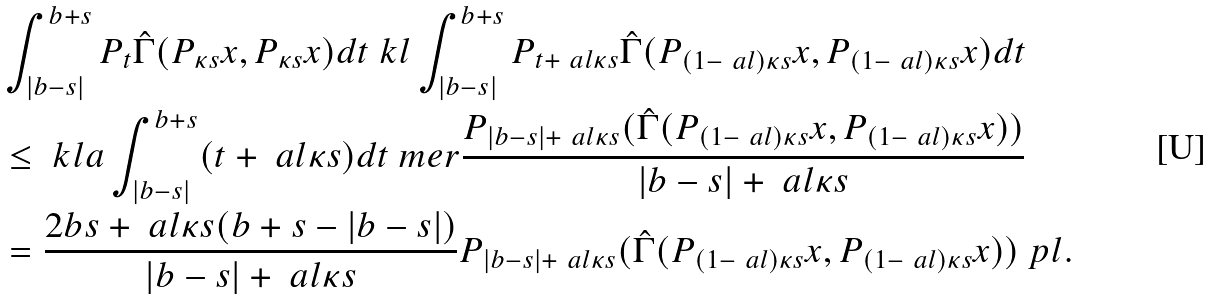<formula> <loc_0><loc_0><loc_500><loc_500>& \int _ { | b - s | } ^ { b + s } P _ { t } \hat { \Gamma } ( P _ { \kappa s } x , P _ { \kappa s } x ) d t \ k l \int _ { | b - s | } ^ { b + s } P _ { t + \ a l \kappa s } \hat { \Gamma } ( P _ { ( 1 - \ a l ) \kappa s } x , P _ { ( 1 - \ a l ) \kappa s } x ) d t \\ & \leq \ k l a \int _ { | b - s | } ^ { b + s } ( t + \ a l \kappa s ) d t \ m e r \frac { P _ { | b - s | + \ a l \kappa s } ( \hat { \Gamma } ( P _ { ( 1 - \ a l ) \kappa s } x , P _ { ( 1 - \ a l ) \kappa s } x ) ) } { | b - s | + \ a l \kappa s } \\ & = \frac { 2 b s + \ a l \kappa s ( b + s - | b - s | ) } { | b - s | + \ a l \kappa s } P _ { | b - s | + \ a l \kappa s } ( \hat { \Gamma } ( P _ { ( 1 - \ a l ) \kappa s } x , P _ { ( 1 - \ a l ) \kappa s } x ) ) \ p l .</formula> 